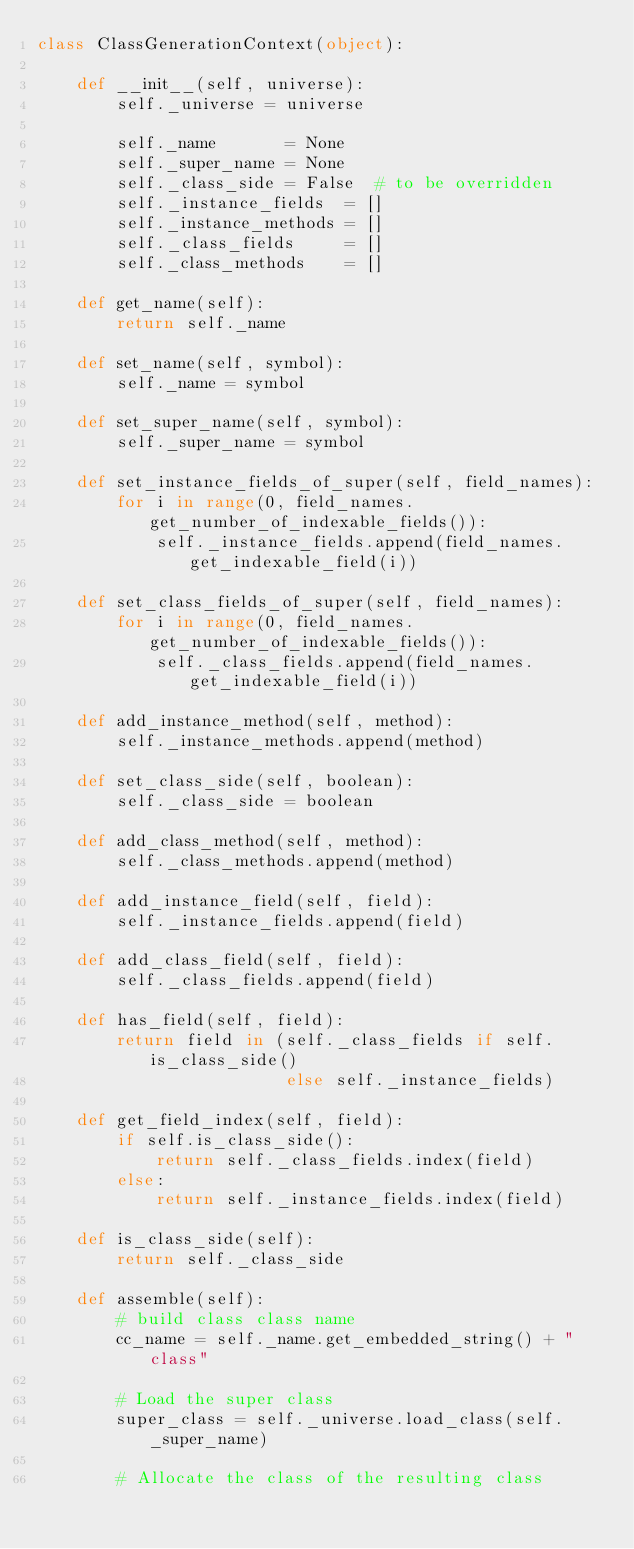Convert code to text. <code><loc_0><loc_0><loc_500><loc_500><_Python_>class ClassGenerationContext(object):

    def __init__(self, universe):
        self._universe = universe

        self._name       = None
        self._super_name = None
        self._class_side = False  # to be overridden
        self._instance_fields  = []
        self._instance_methods = []
        self._class_fields     = []
        self._class_methods    = []

    def get_name(self):
        return self._name

    def set_name(self, symbol):
        self._name = symbol

    def set_super_name(self, symbol):
        self._super_name = symbol

    def set_instance_fields_of_super(self, field_names):
        for i in range(0, field_names.get_number_of_indexable_fields()):
            self._instance_fields.append(field_names.get_indexable_field(i))

    def set_class_fields_of_super(self, field_names):
        for i in range(0, field_names.get_number_of_indexable_fields()):
            self._class_fields.append(field_names.get_indexable_field(i))

    def add_instance_method(self, method):
        self._instance_methods.append(method)

    def set_class_side(self, boolean):
        self._class_side = boolean

    def add_class_method(self, method):
        self._class_methods.append(method)

    def add_instance_field(self, field):
        self._instance_fields.append(field)

    def add_class_field(self, field):
        self._class_fields.append(field)

    def has_field(self, field):
        return field in (self._class_fields if self.is_class_side()
                         else self._instance_fields)

    def get_field_index(self, field):
        if self.is_class_side():
            return self._class_fields.index(field)
        else:
            return self._instance_fields.index(field)

    def is_class_side(self):
        return self._class_side

    def assemble(self):
        # build class class name
        cc_name = self._name.get_embedded_string() + " class"

        # Load the super class
        super_class = self._universe.load_class(self._super_name)

        # Allocate the class of the resulting class</code> 